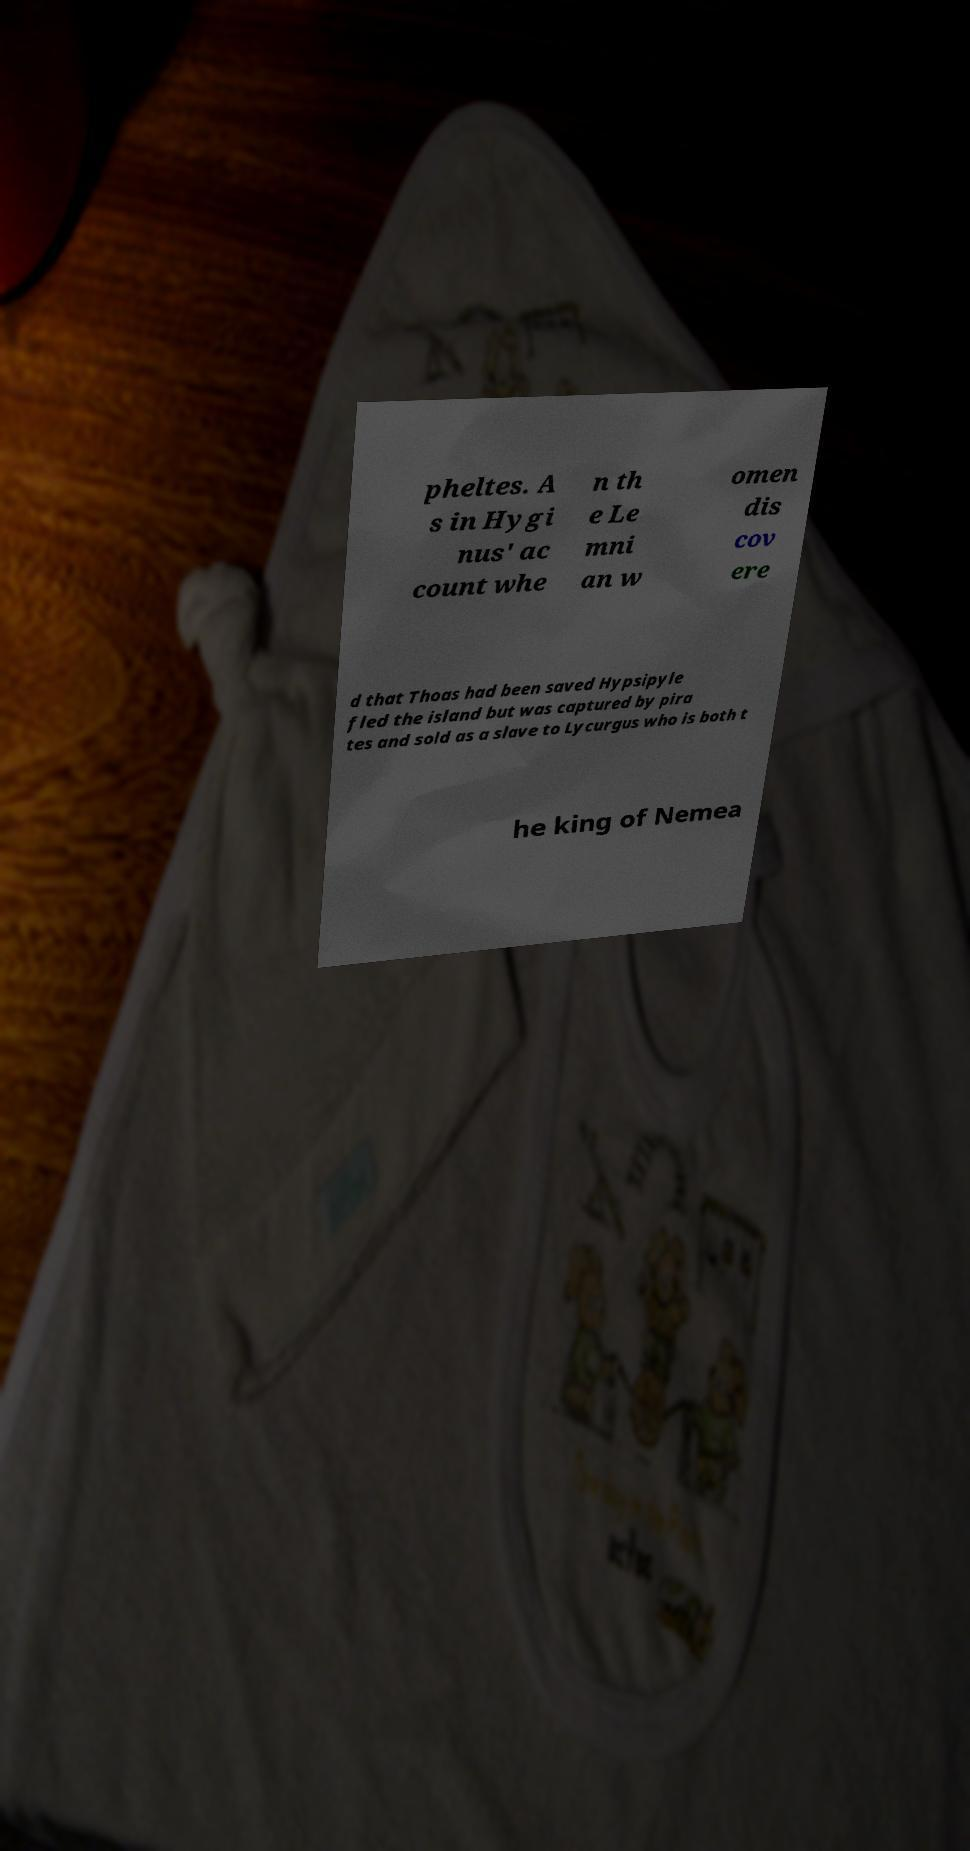Please read and relay the text visible in this image. What does it say? pheltes. A s in Hygi nus' ac count whe n th e Le mni an w omen dis cov ere d that Thoas had been saved Hypsipyle fled the island but was captured by pira tes and sold as a slave to Lycurgus who is both t he king of Nemea 